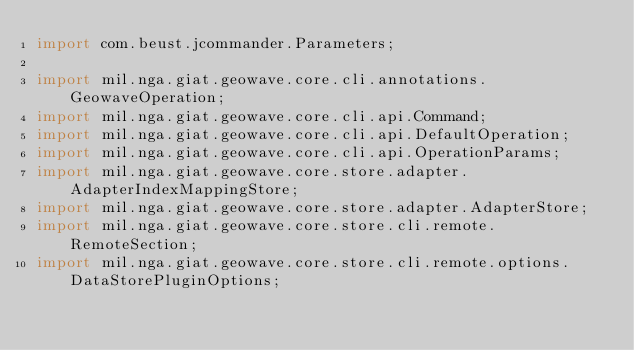Convert code to text. <code><loc_0><loc_0><loc_500><loc_500><_Java_>import com.beust.jcommander.Parameters;

import mil.nga.giat.geowave.core.cli.annotations.GeowaveOperation;
import mil.nga.giat.geowave.core.cli.api.Command;
import mil.nga.giat.geowave.core.cli.api.DefaultOperation;
import mil.nga.giat.geowave.core.cli.api.OperationParams;
import mil.nga.giat.geowave.core.store.adapter.AdapterIndexMappingStore;
import mil.nga.giat.geowave.core.store.adapter.AdapterStore;
import mil.nga.giat.geowave.core.store.cli.remote.RemoteSection;
import mil.nga.giat.geowave.core.store.cli.remote.options.DataStorePluginOptions;</code> 